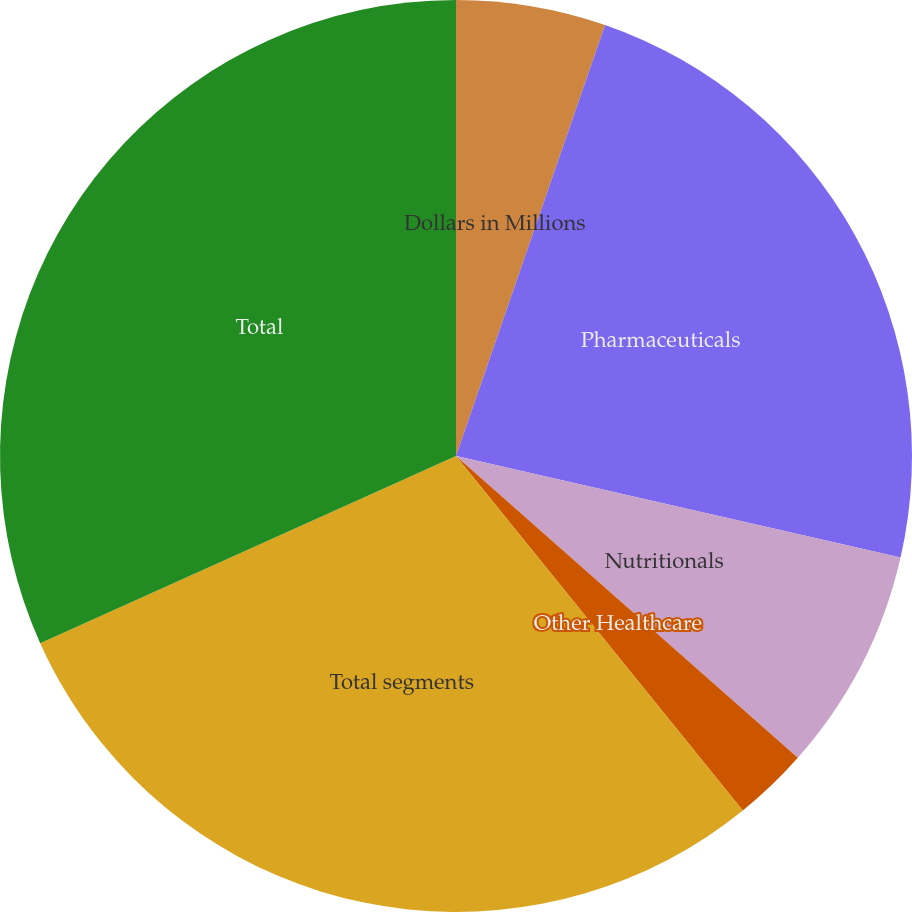<chart> <loc_0><loc_0><loc_500><loc_500><pie_chart><fcel>Dollars in Millions<fcel>Pharmaceuticals<fcel>Nutritionals<fcel>Other Healthcare<fcel>Total segments<fcel>Total<nl><fcel>5.3%<fcel>23.27%<fcel>7.94%<fcel>2.66%<fcel>29.09%<fcel>31.73%<nl></chart> 